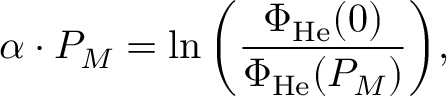Convert formula to latex. <formula><loc_0><loc_0><loc_500><loc_500>\alpha \cdot P _ { M } = \ln { \left ( \frac { \Phi _ { H e } ( 0 ) } { \Phi _ { H e } ( P _ { M } ) } \right ) } ,</formula> 